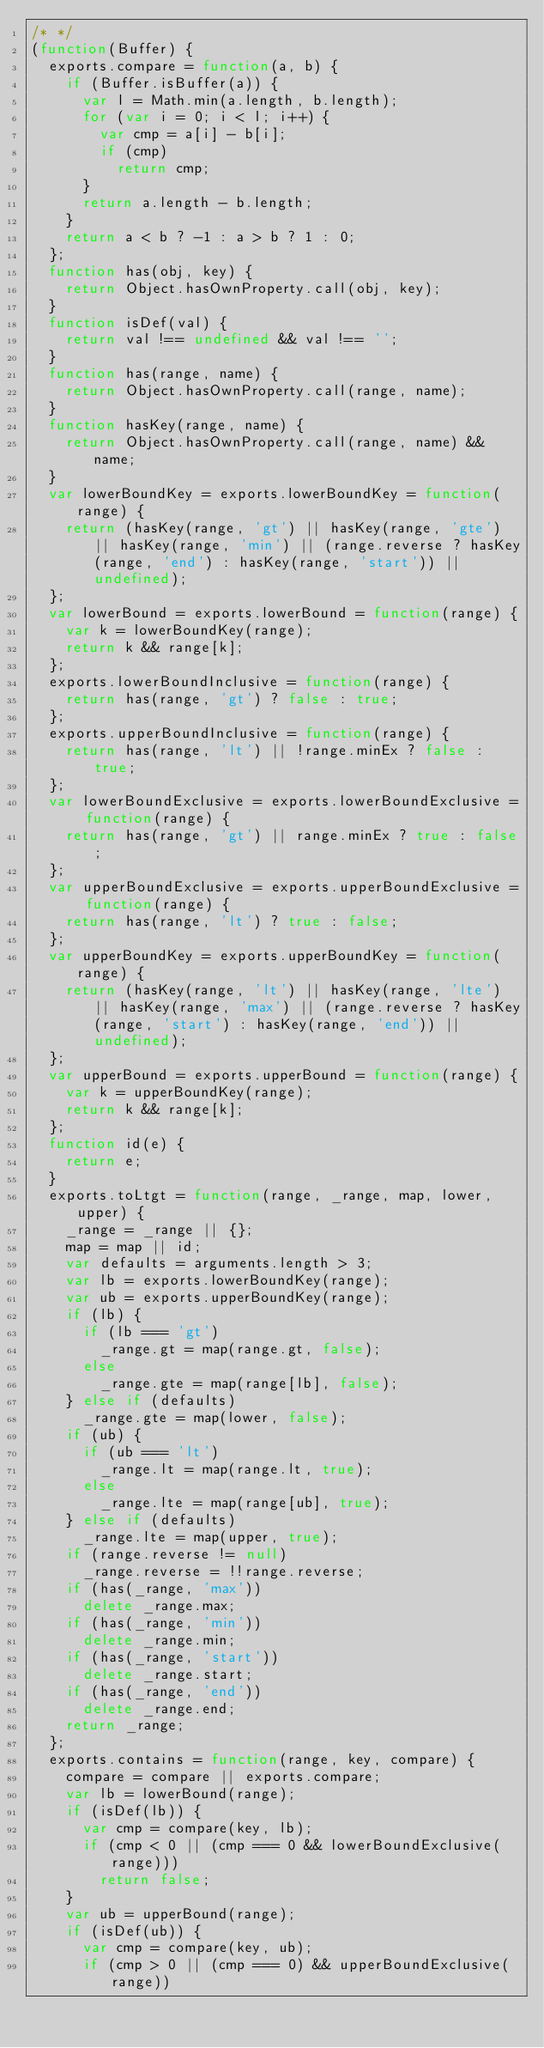<code> <loc_0><loc_0><loc_500><loc_500><_JavaScript_>/* */ 
(function(Buffer) {
  exports.compare = function(a, b) {
    if (Buffer.isBuffer(a)) {
      var l = Math.min(a.length, b.length);
      for (var i = 0; i < l; i++) {
        var cmp = a[i] - b[i];
        if (cmp)
          return cmp;
      }
      return a.length - b.length;
    }
    return a < b ? -1 : a > b ? 1 : 0;
  };
  function has(obj, key) {
    return Object.hasOwnProperty.call(obj, key);
  }
  function isDef(val) {
    return val !== undefined && val !== '';
  }
  function has(range, name) {
    return Object.hasOwnProperty.call(range, name);
  }
  function hasKey(range, name) {
    return Object.hasOwnProperty.call(range, name) && name;
  }
  var lowerBoundKey = exports.lowerBoundKey = function(range) {
    return (hasKey(range, 'gt') || hasKey(range, 'gte') || hasKey(range, 'min') || (range.reverse ? hasKey(range, 'end') : hasKey(range, 'start')) || undefined);
  };
  var lowerBound = exports.lowerBound = function(range) {
    var k = lowerBoundKey(range);
    return k && range[k];
  };
  exports.lowerBoundInclusive = function(range) {
    return has(range, 'gt') ? false : true;
  };
  exports.upperBoundInclusive = function(range) {
    return has(range, 'lt') || !range.minEx ? false : true;
  };
  var lowerBoundExclusive = exports.lowerBoundExclusive = function(range) {
    return has(range, 'gt') || range.minEx ? true : false;
  };
  var upperBoundExclusive = exports.upperBoundExclusive = function(range) {
    return has(range, 'lt') ? true : false;
  };
  var upperBoundKey = exports.upperBoundKey = function(range) {
    return (hasKey(range, 'lt') || hasKey(range, 'lte') || hasKey(range, 'max') || (range.reverse ? hasKey(range, 'start') : hasKey(range, 'end')) || undefined);
  };
  var upperBound = exports.upperBound = function(range) {
    var k = upperBoundKey(range);
    return k && range[k];
  };
  function id(e) {
    return e;
  }
  exports.toLtgt = function(range, _range, map, lower, upper) {
    _range = _range || {};
    map = map || id;
    var defaults = arguments.length > 3;
    var lb = exports.lowerBoundKey(range);
    var ub = exports.upperBoundKey(range);
    if (lb) {
      if (lb === 'gt')
        _range.gt = map(range.gt, false);
      else
        _range.gte = map(range[lb], false);
    } else if (defaults)
      _range.gte = map(lower, false);
    if (ub) {
      if (ub === 'lt')
        _range.lt = map(range.lt, true);
      else
        _range.lte = map(range[ub], true);
    } else if (defaults)
      _range.lte = map(upper, true);
    if (range.reverse != null)
      _range.reverse = !!range.reverse;
    if (has(_range, 'max'))
      delete _range.max;
    if (has(_range, 'min'))
      delete _range.min;
    if (has(_range, 'start'))
      delete _range.start;
    if (has(_range, 'end'))
      delete _range.end;
    return _range;
  };
  exports.contains = function(range, key, compare) {
    compare = compare || exports.compare;
    var lb = lowerBound(range);
    if (isDef(lb)) {
      var cmp = compare(key, lb);
      if (cmp < 0 || (cmp === 0 && lowerBoundExclusive(range)))
        return false;
    }
    var ub = upperBound(range);
    if (isDef(ub)) {
      var cmp = compare(key, ub);
      if (cmp > 0 || (cmp === 0) && upperBoundExclusive(range))</code> 